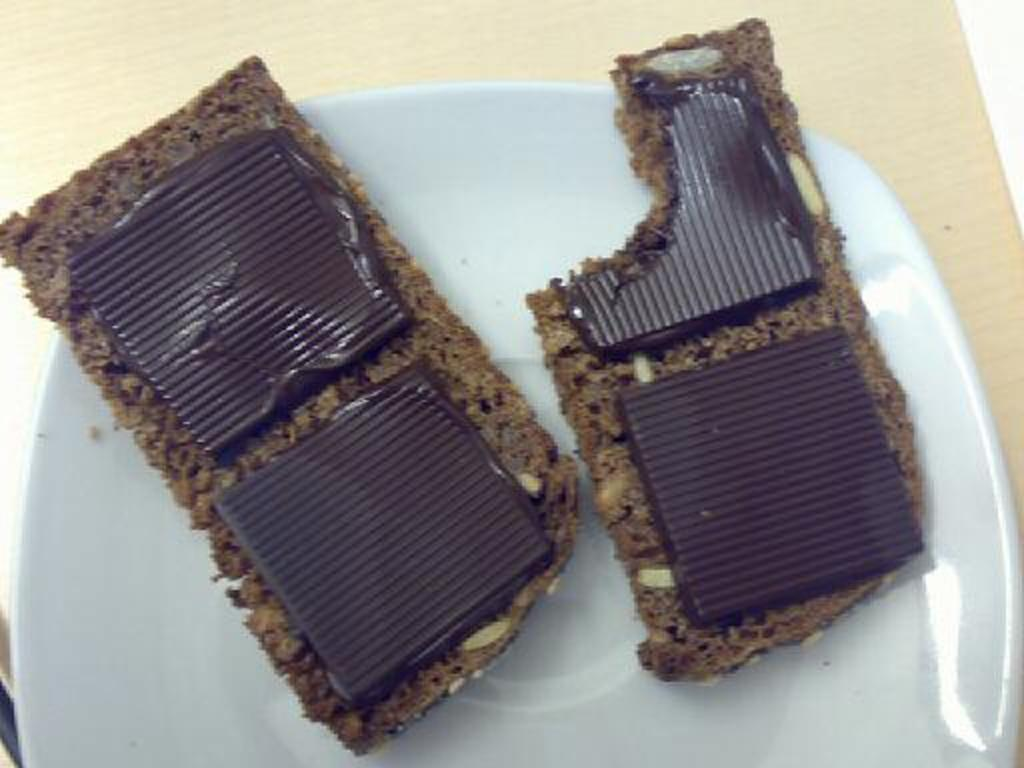What is on the plate that is visible in the image? The plate contains chocolate bars. Where is the plate located in the image? The plate is placed on a table. In what type of setting is the image taken? The image is taken in a room. What type of belief is represented by the chocolate bars in the image? There is no belief represented by the chocolate bars in the image; they are simply a type of food. 